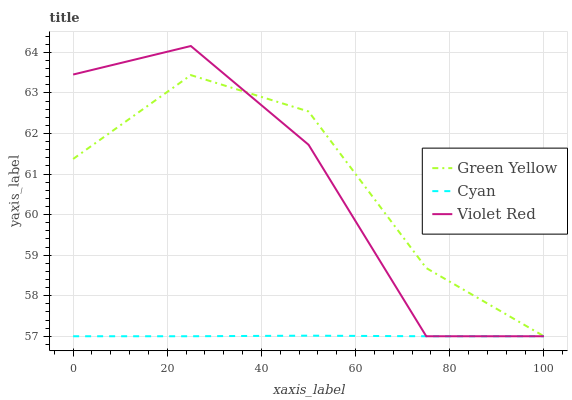Does Cyan have the minimum area under the curve?
Answer yes or no. Yes. Does Green Yellow have the maximum area under the curve?
Answer yes or no. Yes. Does Violet Red have the minimum area under the curve?
Answer yes or no. No. Does Violet Red have the maximum area under the curve?
Answer yes or no. No. Is Cyan the smoothest?
Answer yes or no. Yes. Is Violet Red the roughest?
Answer yes or no. Yes. Is Green Yellow the smoothest?
Answer yes or no. No. Is Green Yellow the roughest?
Answer yes or no. No. Does Cyan have the lowest value?
Answer yes or no. Yes. Does Violet Red have the highest value?
Answer yes or no. Yes. Does Green Yellow have the highest value?
Answer yes or no. No. Does Cyan intersect Violet Red?
Answer yes or no. Yes. Is Cyan less than Violet Red?
Answer yes or no. No. Is Cyan greater than Violet Red?
Answer yes or no. No. 